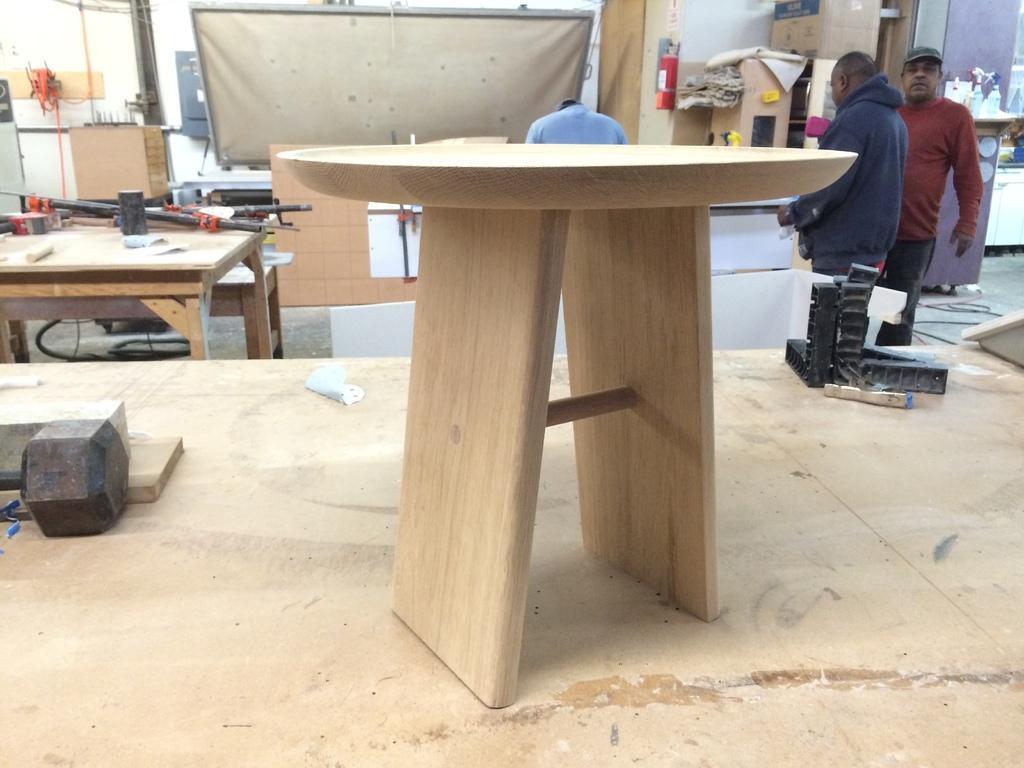Can you describe this image briefly? In this image i can see a table at the back ground i can see two men standing, a pillar, a board, few machines on a table. 